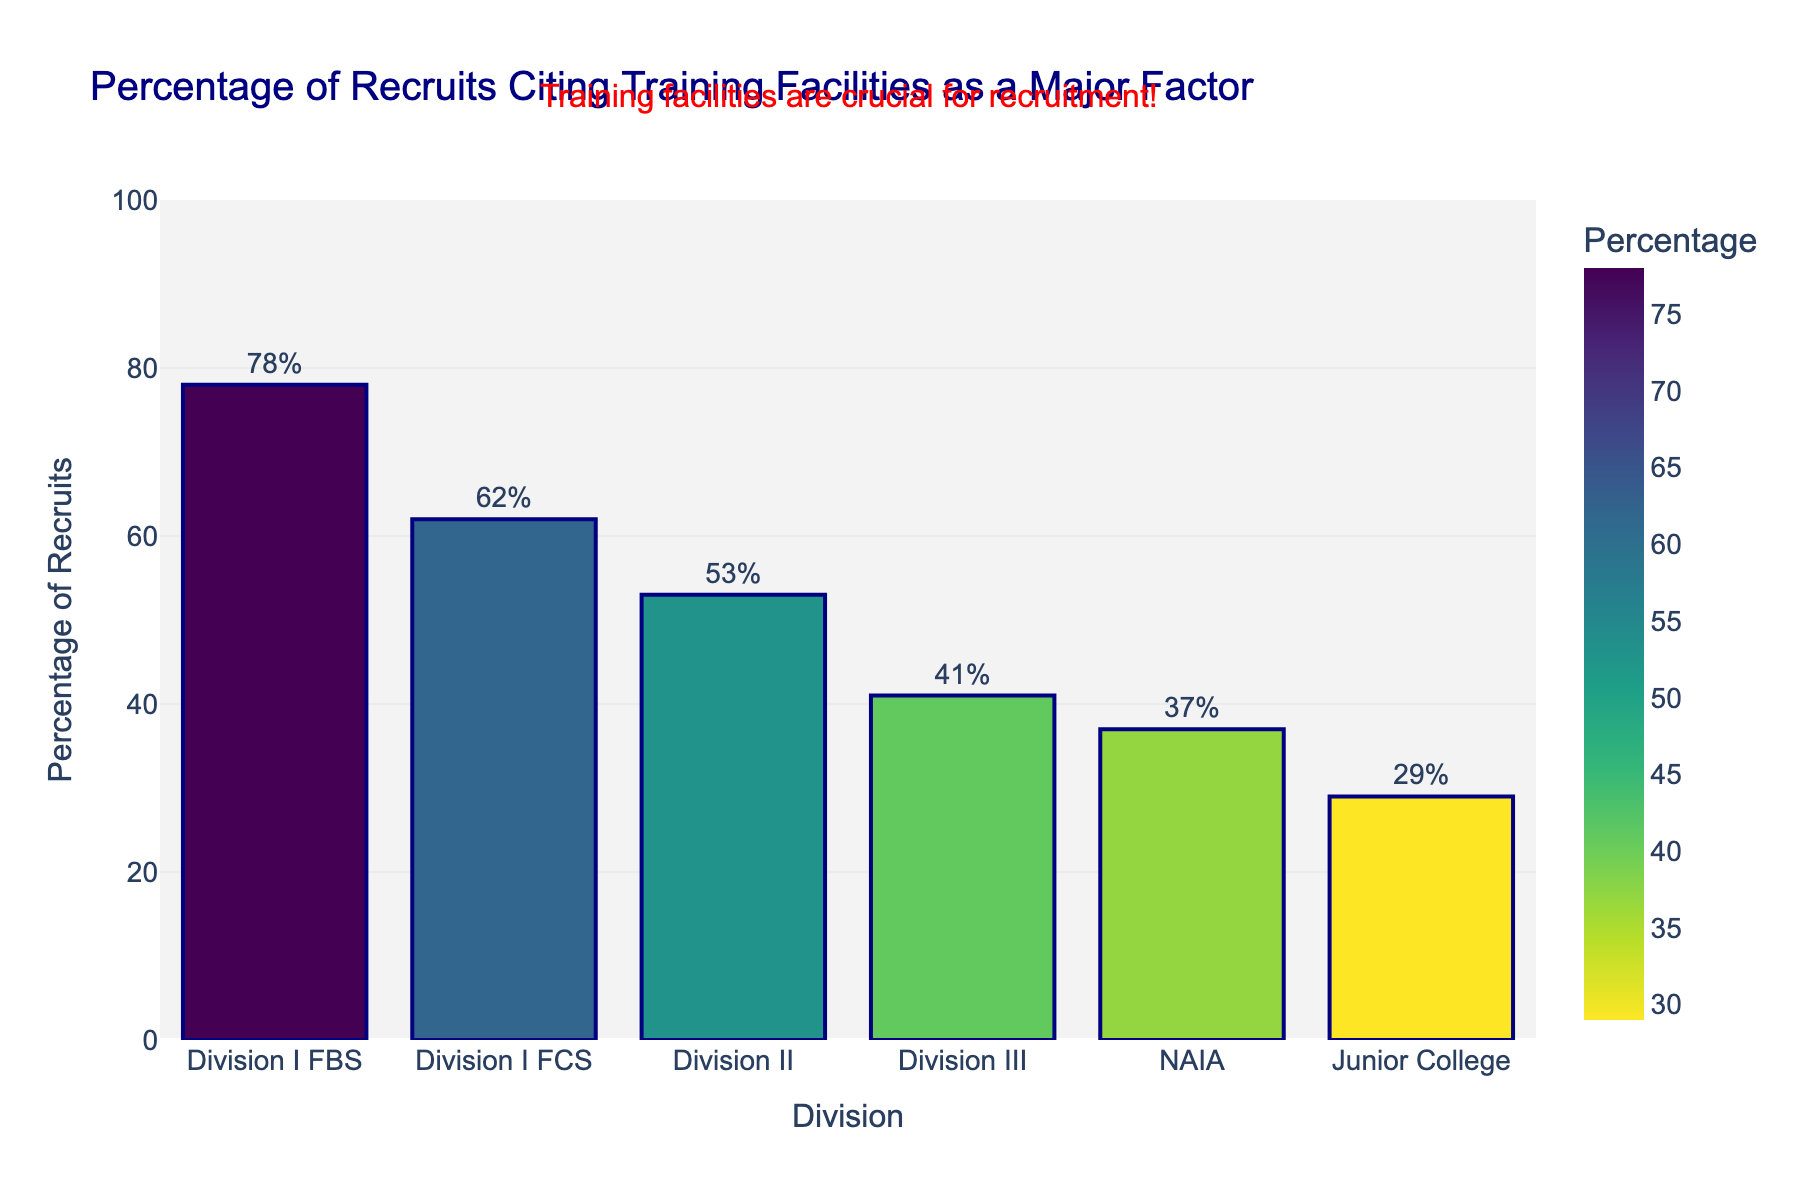Which division has the highest percentage of recruits citing training facilities as a major factor? Division I FBS is the tallest bar in the chart and has the highest percentage value listed.
Answer: Division I FBS Which division has the lowest percentage of recruits citing training facilities as a major factor? Junior College is the shortest bar in the chart and has the lowest percentage value listed.
Answer: Junior College How much higher is the percentage for Division I FBS compared to Division III? Division I FBS has a percentage of 78 whereas Division III has 41. The difference is calculated by 78 - 41.
Answer: 37 What's the average percentage of recruits citing training facilities for Division II and NAIA? Add the percentages of Division II (53) and NAIA (37) and then divide by 2. (53 + 37) / 2 = 45
Answer: 45 What's the sum of the percentages for Division I FCS, Division II, and Junior College? Add the percentages of Division I FCS (62), Division II (53), and Junior College (29). 62 + 53 + 29 = 144
Answer: 144 Which two divisions have the closest percentage of recruits citing training facilities as a major factor? Divisions III and NAIA have the closest percentages with 41 and 37 respectively, making a difference of 4.
Answer: Division III and NAIA How many divisions have a percentage of recruits citing training facilities as above 50%? Division I FBS, Division I FCS, and Division II all have percentages above 50%: 78%, 62%, and 53%.
Answer: 3 What percentage of recruits cite training facilities as a major factor in Division I FBS and how does it compare to Division I FCS? The percentage for Division I FBS is 78%, which is higher than the 62% for Division I FCS.
Answer: 78%, higher Is the percentage of recruits citing training facilities for Division II closer to Division I FCS or Division III? Division II has 53%, which is closer to Division I FCS at 62% than to Division III at 41%.
Answer: Division I FCS If you combine the percentages of recruits for Division I FCS and NAIA, how does it compare to Division I FBS alone? The combined percentage for Division I FCS (62) and NAIA (37) is 99, which is higher than Division I FBS at 78. 62 + 37 = 99
Answer: 99, higher 